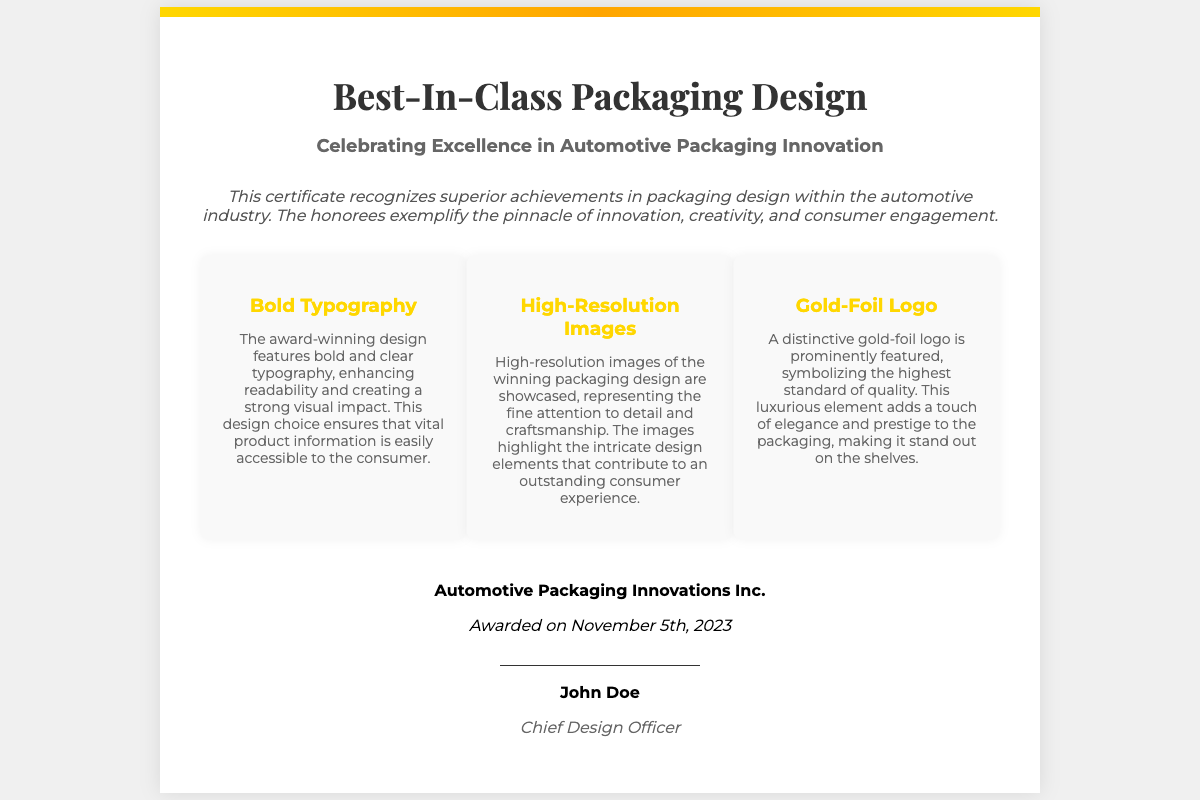What is the title of the certificate? The title of the certificate is prominently displayed at the top of the document.
Answer: Best-In-Class Packaging Design What is the subtitle of the certificate? The subtitle provides additional context and is located just below the title.
Answer: Celebrating Excellence in Automotive Packaging Innovation Who is the certificate awarded to? The name of the company receiving the award appears in the footer section.
Answer: Automotive Packaging Innovations Inc What date was the award given? The date of the award is mentioned in the footer of the document.
Answer: November 5th, 2023 Who is the signatory of the certificate? The signatory's name is located right above the signature line at the bottom of the certificate.
Answer: John Doe What is the title of the signatory? The title of the signatory is mentioned below their name in the signature section.
Answer: Chief Design Officer What design element adds prestige to the packaging? The document highlights a distinctive feature that symbolizes quality in the award-winning design.
Answer: Gold-Foil Logo What type of typography is featured in the design? The document specifies the style of typography used in the winning design.
Answer: Bold Typography What type of images are showcased in the certificate? The document mentions the quality of images highlighted in the design.
Answer: High-Resolution Images 